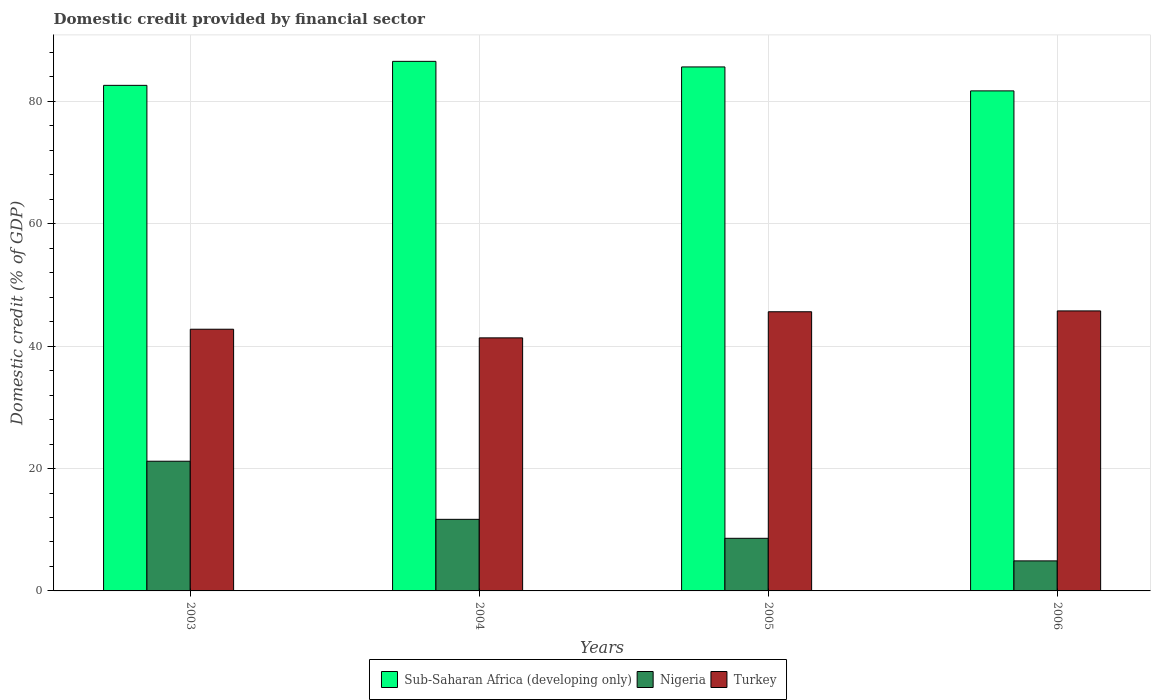How many groups of bars are there?
Your response must be concise. 4. Are the number of bars per tick equal to the number of legend labels?
Offer a terse response. Yes. How many bars are there on the 2nd tick from the right?
Make the answer very short. 3. What is the label of the 2nd group of bars from the left?
Give a very brief answer. 2004. What is the domestic credit in Sub-Saharan Africa (developing only) in 2005?
Offer a terse response. 85.64. Across all years, what is the maximum domestic credit in Nigeria?
Your answer should be compact. 21.2. Across all years, what is the minimum domestic credit in Sub-Saharan Africa (developing only)?
Keep it short and to the point. 81.73. In which year was the domestic credit in Nigeria maximum?
Make the answer very short. 2003. What is the total domestic credit in Nigeria in the graph?
Keep it short and to the point. 46.41. What is the difference between the domestic credit in Turkey in 2004 and that in 2006?
Your answer should be very brief. -4.41. What is the difference between the domestic credit in Nigeria in 2006 and the domestic credit in Sub-Saharan Africa (developing only) in 2004?
Provide a short and direct response. -81.65. What is the average domestic credit in Nigeria per year?
Provide a succinct answer. 11.6. In the year 2006, what is the difference between the domestic credit in Sub-Saharan Africa (developing only) and domestic credit in Turkey?
Your answer should be compact. 35.96. What is the ratio of the domestic credit in Turkey in 2005 to that in 2006?
Your response must be concise. 1. What is the difference between the highest and the second highest domestic credit in Sub-Saharan Africa (developing only)?
Provide a succinct answer. 0.91. What is the difference between the highest and the lowest domestic credit in Nigeria?
Your response must be concise. 16.29. What does the 3rd bar from the left in 2005 represents?
Provide a succinct answer. Turkey. What does the 3rd bar from the right in 2003 represents?
Give a very brief answer. Sub-Saharan Africa (developing only). Is it the case that in every year, the sum of the domestic credit in Nigeria and domestic credit in Sub-Saharan Africa (developing only) is greater than the domestic credit in Turkey?
Your response must be concise. Yes. How many bars are there?
Keep it short and to the point. 12. Are the values on the major ticks of Y-axis written in scientific E-notation?
Offer a very short reply. No. Does the graph contain any zero values?
Ensure brevity in your answer.  No. Where does the legend appear in the graph?
Give a very brief answer. Bottom center. How many legend labels are there?
Provide a short and direct response. 3. What is the title of the graph?
Keep it short and to the point. Domestic credit provided by financial sector. Does "Ukraine" appear as one of the legend labels in the graph?
Ensure brevity in your answer.  No. What is the label or title of the X-axis?
Provide a short and direct response. Years. What is the label or title of the Y-axis?
Provide a short and direct response. Domestic credit (% of GDP). What is the Domestic credit (% of GDP) of Sub-Saharan Africa (developing only) in 2003?
Ensure brevity in your answer.  82.63. What is the Domestic credit (% of GDP) in Nigeria in 2003?
Offer a very short reply. 21.2. What is the Domestic credit (% of GDP) of Turkey in 2003?
Your response must be concise. 42.77. What is the Domestic credit (% of GDP) of Sub-Saharan Africa (developing only) in 2004?
Your answer should be very brief. 86.56. What is the Domestic credit (% of GDP) of Nigeria in 2004?
Give a very brief answer. 11.7. What is the Domestic credit (% of GDP) of Turkey in 2004?
Provide a short and direct response. 41.36. What is the Domestic credit (% of GDP) in Sub-Saharan Africa (developing only) in 2005?
Offer a terse response. 85.64. What is the Domestic credit (% of GDP) of Nigeria in 2005?
Offer a very short reply. 8.6. What is the Domestic credit (% of GDP) of Turkey in 2005?
Give a very brief answer. 45.63. What is the Domestic credit (% of GDP) in Sub-Saharan Africa (developing only) in 2006?
Your response must be concise. 81.73. What is the Domestic credit (% of GDP) in Nigeria in 2006?
Provide a short and direct response. 4.91. What is the Domestic credit (% of GDP) of Turkey in 2006?
Your answer should be compact. 45.77. Across all years, what is the maximum Domestic credit (% of GDP) of Sub-Saharan Africa (developing only)?
Ensure brevity in your answer.  86.56. Across all years, what is the maximum Domestic credit (% of GDP) of Nigeria?
Give a very brief answer. 21.2. Across all years, what is the maximum Domestic credit (% of GDP) in Turkey?
Give a very brief answer. 45.77. Across all years, what is the minimum Domestic credit (% of GDP) of Sub-Saharan Africa (developing only)?
Your answer should be compact. 81.73. Across all years, what is the minimum Domestic credit (% of GDP) of Nigeria?
Your answer should be very brief. 4.91. Across all years, what is the minimum Domestic credit (% of GDP) of Turkey?
Your answer should be compact. 41.36. What is the total Domestic credit (% of GDP) of Sub-Saharan Africa (developing only) in the graph?
Offer a terse response. 336.56. What is the total Domestic credit (% of GDP) of Nigeria in the graph?
Your answer should be very brief. 46.41. What is the total Domestic credit (% of GDP) in Turkey in the graph?
Provide a succinct answer. 175.53. What is the difference between the Domestic credit (% of GDP) of Sub-Saharan Africa (developing only) in 2003 and that in 2004?
Keep it short and to the point. -3.92. What is the difference between the Domestic credit (% of GDP) of Nigeria in 2003 and that in 2004?
Keep it short and to the point. 9.5. What is the difference between the Domestic credit (% of GDP) in Turkey in 2003 and that in 2004?
Your response must be concise. 1.41. What is the difference between the Domestic credit (% of GDP) in Sub-Saharan Africa (developing only) in 2003 and that in 2005?
Make the answer very short. -3.01. What is the difference between the Domestic credit (% of GDP) in Nigeria in 2003 and that in 2005?
Your answer should be very brief. 12.6. What is the difference between the Domestic credit (% of GDP) in Turkey in 2003 and that in 2005?
Provide a short and direct response. -2.85. What is the difference between the Domestic credit (% of GDP) of Sub-Saharan Africa (developing only) in 2003 and that in 2006?
Keep it short and to the point. 0.9. What is the difference between the Domestic credit (% of GDP) of Nigeria in 2003 and that in 2006?
Keep it short and to the point. 16.29. What is the difference between the Domestic credit (% of GDP) in Turkey in 2003 and that in 2006?
Offer a very short reply. -2.99. What is the difference between the Domestic credit (% of GDP) of Sub-Saharan Africa (developing only) in 2004 and that in 2005?
Keep it short and to the point. 0.91. What is the difference between the Domestic credit (% of GDP) of Nigeria in 2004 and that in 2005?
Offer a very short reply. 3.1. What is the difference between the Domestic credit (% of GDP) in Turkey in 2004 and that in 2005?
Keep it short and to the point. -4.27. What is the difference between the Domestic credit (% of GDP) in Sub-Saharan Africa (developing only) in 2004 and that in 2006?
Offer a terse response. 4.83. What is the difference between the Domestic credit (% of GDP) of Nigeria in 2004 and that in 2006?
Your answer should be very brief. 6.79. What is the difference between the Domestic credit (% of GDP) in Turkey in 2004 and that in 2006?
Provide a short and direct response. -4.41. What is the difference between the Domestic credit (% of GDP) of Sub-Saharan Africa (developing only) in 2005 and that in 2006?
Give a very brief answer. 3.92. What is the difference between the Domestic credit (% of GDP) of Nigeria in 2005 and that in 2006?
Ensure brevity in your answer.  3.69. What is the difference between the Domestic credit (% of GDP) in Turkey in 2005 and that in 2006?
Offer a terse response. -0.14. What is the difference between the Domestic credit (% of GDP) in Sub-Saharan Africa (developing only) in 2003 and the Domestic credit (% of GDP) in Nigeria in 2004?
Provide a short and direct response. 70.93. What is the difference between the Domestic credit (% of GDP) in Sub-Saharan Africa (developing only) in 2003 and the Domestic credit (% of GDP) in Turkey in 2004?
Provide a succinct answer. 41.27. What is the difference between the Domestic credit (% of GDP) in Nigeria in 2003 and the Domestic credit (% of GDP) in Turkey in 2004?
Offer a very short reply. -20.16. What is the difference between the Domestic credit (% of GDP) of Sub-Saharan Africa (developing only) in 2003 and the Domestic credit (% of GDP) of Nigeria in 2005?
Provide a succinct answer. 74.03. What is the difference between the Domestic credit (% of GDP) in Sub-Saharan Africa (developing only) in 2003 and the Domestic credit (% of GDP) in Turkey in 2005?
Offer a terse response. 37. What is the difference between the Domestic credit (% of GDP) in Nigeria in 2003 and the Domestic credit (% of GDP) in Turkey in 2005?
Make the answer very short. -24.43. What is the difference between the Domestic credit (% of GDP) in Sub-Saharan Africa (developing only) in 2003 and the Domestic credit (% of GDP) in Nigeria in 2006?
Provide a succinct answer. 77.72. What is the difference between the Domestic credit (% of GDP) in Sub-Saharan Africa (developing only) in 2003 and the Domestic credit (% of GDP) in Turkey in 2006?
Keep it short and to the point. 36.87. What is the difference between the Domestic credit (% of GDP) in Nigeria in 2003 and the Domestic credit (% of GDP) in Turkey in 2006?
Give a very brief answer. -24.57. What is the difference between the Domestic credit (% of GDP) in Sub-Saharan Africa (developing only) in 2004 and the Domestic credit (% of GDP) in Nigeria in 2005?
Your answer should be very brief. 77.96. What is the difference between the Domestic credit (% of GDP) of Sub-Saharan Africa (developing only) in 2004 and the Domestic credit (% of GDP) of Turkey in 2005?
Your response must be concise. 40.93. What is the difference between the Domestic credit (% of GDP) in Nigeria in 2004 and the Domestic credit (% of GDP) in Turkey in 2005?
Give a very brief answer. -33.93. What is the difference between the Domestic credit (% of GDP) in Sub-Saharan Africa (developing only) in 2004 and the Domestic credit (% of GDP) in Nigeria in 2006?
Keep it short and to the point. 81.65. What is the difference between the Domestic credit (% of GDP) of Sub-Saharan Africa (developing only) in 2004 and the Domestic credit (% of GDP) of Turkey in 2006?
Offer a terse response. 40.79. What is the difference between the Domestic credit (% of GDP) in Nigeria in 2004 and the Domestic credit (% of GDP) in Turkey in 2006?
Your response must be concise. -34.06. What is the difference between the Domestic credit (% of GDP) of Sub-Saharan Africa (developing only) in 2005 and the Domestic credit (% of GDP) of Nigeria in 2006?
Your answer should be very brief. 80.73. What is the difference between the Domestic credit (% of GDP) in Sub-Saharan Africa (developing only) in 2005 and the Domestic credit (% of GDP) in Turkey in 2006?
Your response must be concise. 39.88. What is the difference between the Domestic credit (% of GDP) in Nigeria in 2005 and the Domestic credit (% of GDP) in Turkey in 2006?
Your answer should be compact. -37.16. What is the average Domestic credit (% of GDP) in Sub-Saharan Africa (developing only) per year?
Give a very brief answer. 84.14. What is the average Domestic credit (% of GDP) in Nigeria per year?
Your answer should be compact. 11.6. What is the average Domestic credit (% of GDP) of Turkey per year?
Offer a terse response. 43.88. In the year 2003, what is the difference between the Domestic credit (% of GDP) of Sub-Saharan Africa (developing only) and Domestic credit (% of GDP) of Nigeria?
Make the answer very short. 61.44. In the year 2003, what is the difference between the Domestic credit (% of GDP) of Sub-Saharan Africa (developing only) and Domestic credit (% of GDP) of Turkey?
Your answer should be compact. 39.86. In the year 2003, what is the difference between the Domestic credit (% of GDP) of Nigeria and Domestic credit (% of GDP) of Turkey?
Keep it short and to the point. -21.58. In the year 2004, what is the difference between the Domestic credit (% of GDP) in Sub-Saharan Africa (developing only) and Domestic credit (% of GDP) in Nigeria?
Provide a short and direct response. 74.85. In the year 2004, what is the difference between the Domestic credit (% of GDP) in Sub-Saharan Africa (developing only) and Domestic credit (% of GDP) in Turkey?
Your answer should be very brief. 45.2. In the year 2004, what is the difference between the Domestic credit (% of GDP) of Nigeria and Domestic credit (% of GDP) of Turkey?
Give a very brief answer. -29.66. In the year 2005, what is the difference between the Domestic credit (% of GDP) of Sub-Saharan Africa (developing only) and Domestic credit (% of GDP) of Nigeria?
Your answer should be compact. 77.04. In the year 2005, what is the difference between the Domestic credit (% of GDP) in Sub-Saharan Africa (developing only) and Domestic credit (% of GDP) in Turkey?
Your response must be concise. 40.02. In the year 2005, what is the difference between the Domestic credit (% of GDP) of Nigeria and Domestic credit (% of GDP) of Turkey?
Offer a very short reply. -37.03. In the year 2006, what is the difference between the Domestic credit (% of GDP) in Sub-Saharan Africa (developing only) and Domestic credit (% of GDP) in Nigeria?
Your answer should be very brief. 76.82. In the year 2006, what is the difference between the Domestic credit (% of GDP) in Sub-Saharan Africa (developing only) and Domestic credit (% of GDP) in Turkey?
Your answer should be very brief. 35.96. In the year 2006, what is the difference between the Domestic credit (% of GDP) in Nigeria and Domestic credit (% of GDP) in Turkey?
Provide a short and direct response. -40.86. What is the ratio of the Domestic credit (% of GDP) in Sub-Saharan Africa (developing only) in 2003 to that in 2004?
Provide a short and direct response. 0.95. What is the ratio of the Domestic credit (% of GDP) of Nigeria in 2003 to that in 2004?
Provide a succinct answer. 1.81. What is the ratio of the Domestic credit (% of GDP) of Turkey in 2003 to that in 2004?
Give a very brief answer. 1.03. What is the ratio of the Domestic credit (% of GDP) of Sub-Saharan Africa (developing only) in 2003 to that in 2005?
Provide a short and direct response. 0.96. What is the ratio of the Domestic credit (% of GDP) of Nigeria in 2003 to that in 2005?
Make the answer very short. 2.46. What is the ratio of the Domestic credit (% of GDP) in Turkey in 2003 to that in 2005?
Provide a short and direct response. 0.94. What is the ratio of the Domestic credit (% of GDP) in Sub-Saharan Africa (developing only) in 2003 to that in 2006?
Keep it short and to the point. 1.01. What is the ratio of the Domestic credit (% of GDP) of Nigeria in 2003 to that in 2006?
Provide a short and direct response. 4.32. What is the ratio of the Domestic credit (% of GDP) in Turkey in 2003 to that in 2006?
Provide a succinct answer. 0.93. What is the ratio of the Domestic credit (% of GDP) in Sub-Saharan Africa (developing only) in 2004 to that in 2005?
Your response must be concise. 1.01. What is the ratio of the Domestic credit (% of GDP) in Nigeria in 2004 to that in 2005?
Give a very brief answer. 1.36. What is the ratio of the Domestic credit (% of GDP) in Turkey in 2004 to that in 2005?
Your response must be concise. 0.91. What is the ratio of the Domestic credit (% of GDP) of Sub-Saharan Africa (developing only) in 2004 to that in 2006?
Make the answer very short. 1.06. What is the ratio of the Domestic credit (% of GDP) in Nigeria in 2004 to that in 2006?
Provide a succinct answer. 2.38. What is the ratio of the Domestic credit (% of GDP) in Turkey in 2004 to that in 2006?
Your answer should be very brief. 0.9. What is the ratio of the Domestic credit (% of GDP) of Sub-Saharan Africa (developing only) in 2005 to that in 2006?
Offer a terse response. 1.05. What is the ratio of the Domestic credit (% of GDP) in Nigeria in 2005 to that in 2006?
Ensure brevity in your answer.  1.75. What is the difference between the highest and the second highest Domestic credit (% of GDP) in Sub-Saharan Africa (developing only)?
Provide a succinct answer. 0.91. What is the difference between the highest and the second highest Domestic credit (% of GDP) of Nigeria?
Provide a short and direct response. 9.5. What is the difference between the highest and the second highest Domestic credit (% of GDP) of Turkey?
Provide a short and direct response. 0.14. What is the difference between the highest and the lowest Domestic credit (% of GDP) of Sub-Saharan Africa (developing only)?
Keep it short and to the point. 4.83. What is the difference between the highest and the lowest Domestic credit (% of GDP) of Nigeria?
Offer a terse response. 16.29. What is the difference between the highest and the lowest Domestic credit (% of GDP) of Turkey?
Provide a succinct answer. 4.41. 